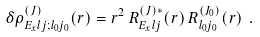Convert formula to latex. <formula><loc_0><loc_0><loc_500><loc_500>\delta \rho _ { E _ { x } l j ; l _ { 0 } j _ { 0 } } ^ { ( J ) } ( r ) = r ^ { 2 } \, R _ { E _ { x } l j } ^ { ( J ) * } ( r ) \, R _ { l _ { 0 } j _ { 0 } } ^ { ( J _ { 0 } ) } ( r ) \ .</formula> 